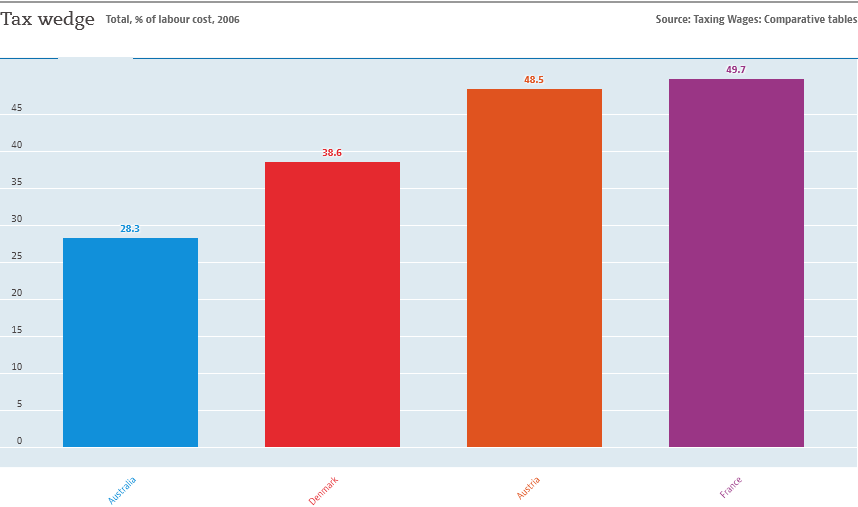Mention a couple of crucial points in this snapshot. In the graph, find and separately calculate the sum of the two lowest values. The value of the tallest bar in the histogram is approximately 0.497. 